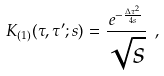<formula> <loc_0><loc_0><loc_500><loc_500>K _ { ( 1 ) } ( \tau , \tau ^ { \prime } ; s ) = \frac { e ^ { - \frac { \Delta \tau ^ { 2 } } { 4 s } } } { \sqrt { s } } \ ,</formula> 